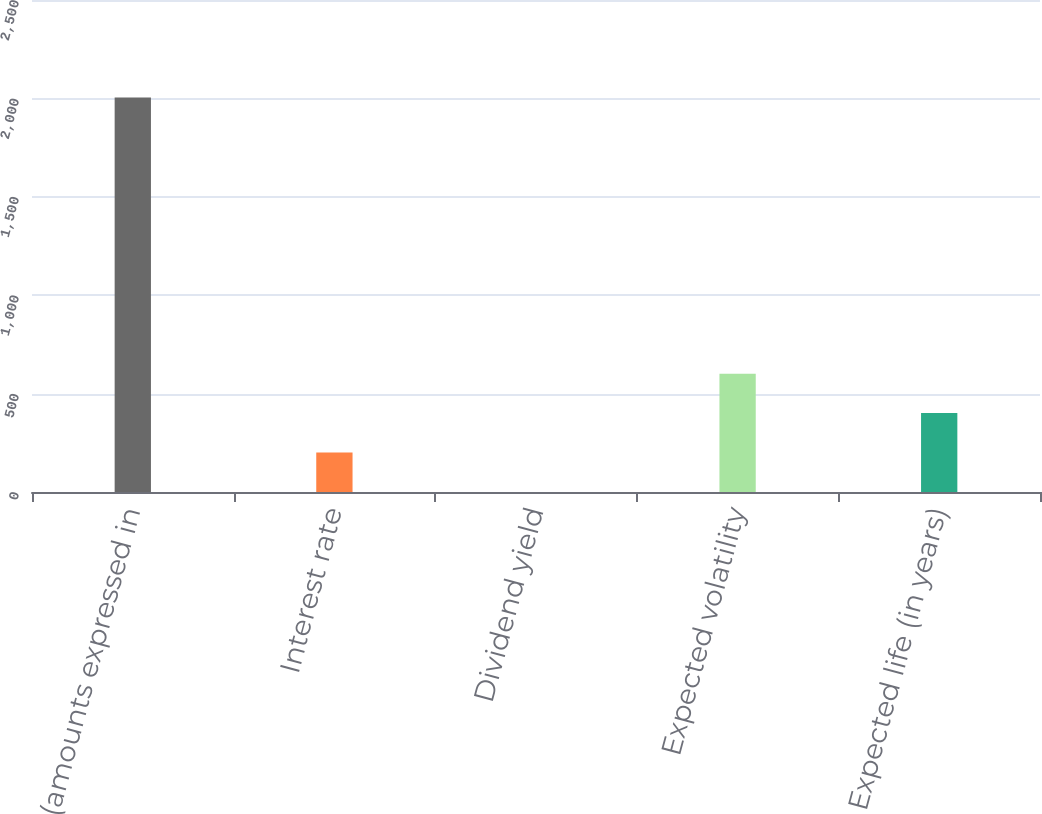<chart> <loc_0><loc_0><loc_500><loc_500><bar_chart><fcel>(amounts expressed in<fcel>Interest rate<fcel>Dividend yield<fcel>Expected volatility<fcel>Expected life (in years)<nl><fcel>2004<fcel>200.69<fcel>0.32<fcel>601.43<fcel>401.06<nl></chart> 